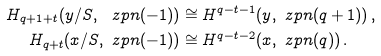Convert formula to latex. <formula><loc_0><loc_0><loc_500><loc_500>H _ { q + 1 + t } ( y / S , \ z p n ( - 1 ) ) & \cong H ^ { q - t - 1 } ( y , \ z p n ( q + 1 ) ) \, , \\ H _ { q + t } ( x / S , \ z p n ( - 1 ) ) & \cong H ^ { q - t - 2 } ( x , \ z p n ( q ) ) \, .</formula> 